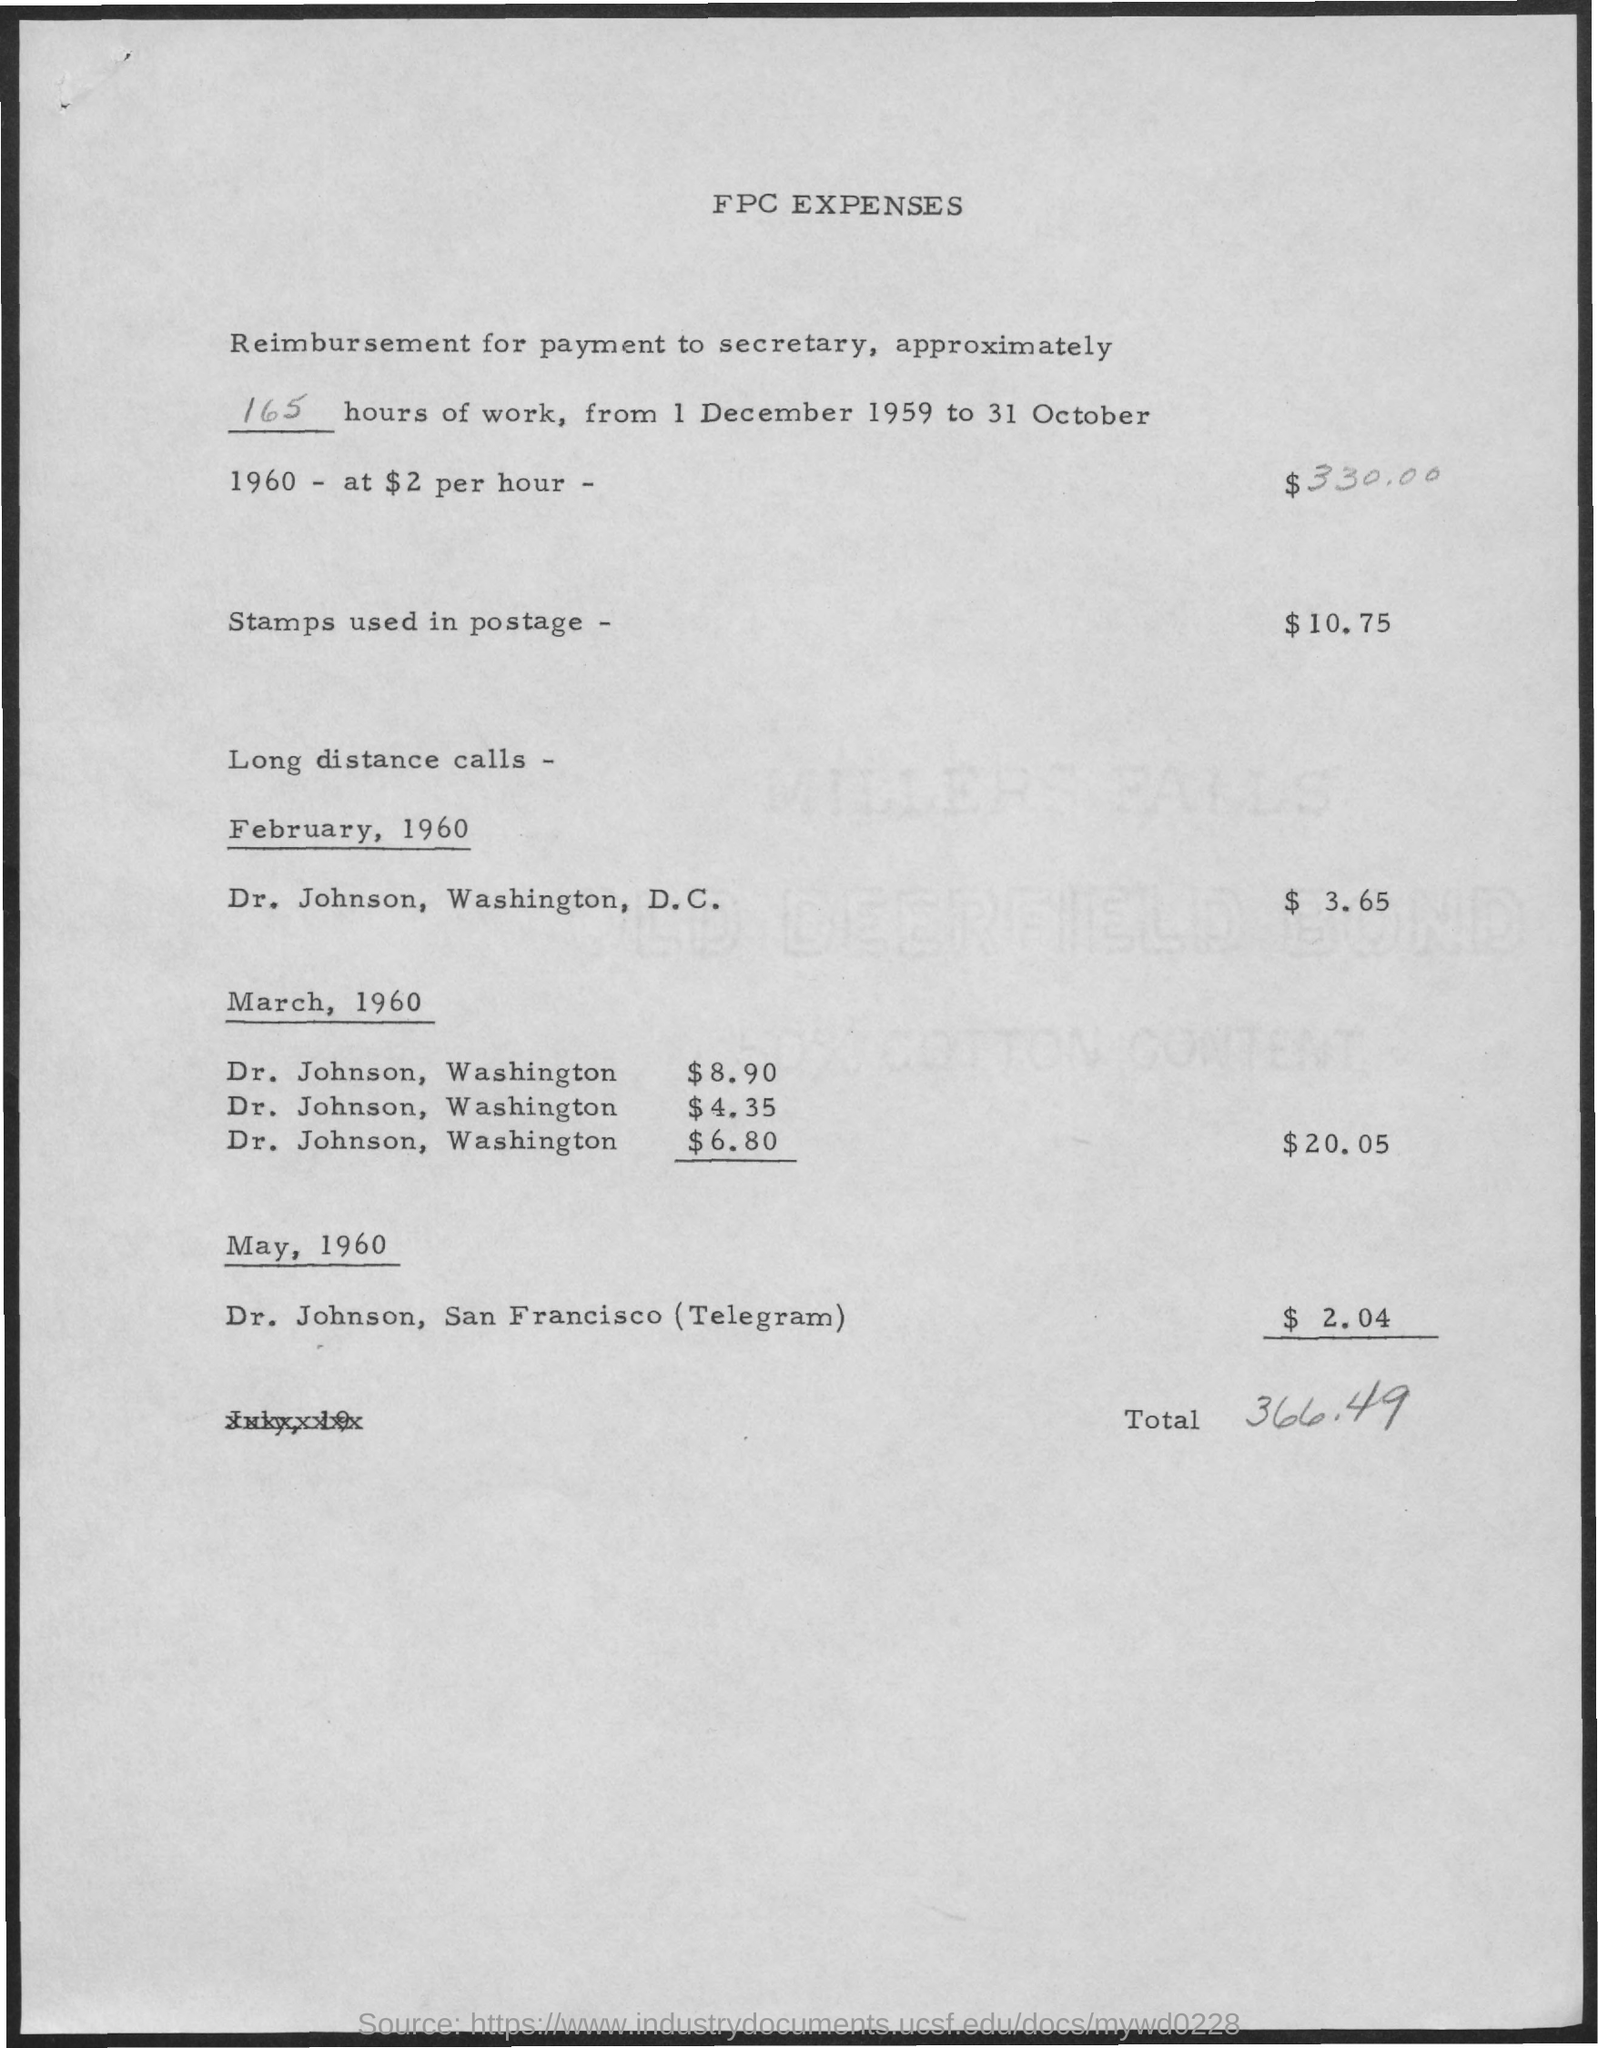Draw attention to some important aspects in this diagram. The total amount of FPC expenses is 366.49. The amount related to stamps used in postage is $10.75. The charge for Telegram to Dr. Johnson in San Francisco is 2.04 cents. The heading of the data is "FPC Expenses. On March 1960, the total charges for long distance calls were $20.05. 